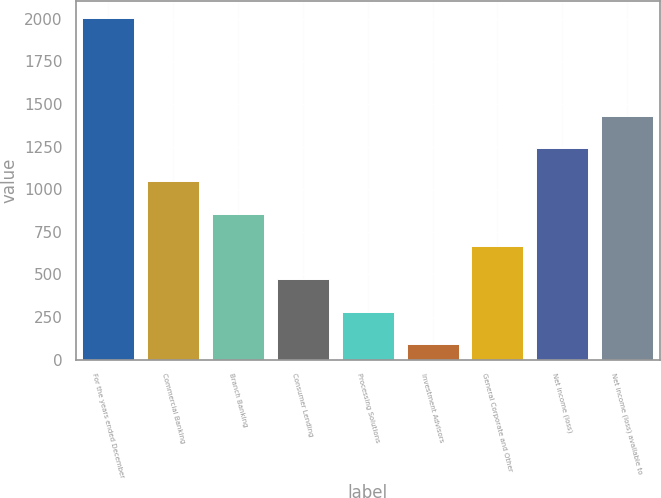<chart> <loc_0><loc_0><loc_500><loc_500><bar_chart><fcel>For the years ended December<fcel>Commercial Banking<fcel>Branch Banking<fcel>Consumer Lending<fcel>Processing Solutions<fcel>Investment Advisors<fcel>General Corporate and Other<fcel>Net income (loss)<fcel>Net income (loss) available to<nl><fcel>2006<fcel>1048<fcel>856.4<fcel>473.2<fcel>281.6<fcel>90<fcel>664.8<fcel>1239.6<fcel>1431.2<nl></chart> 